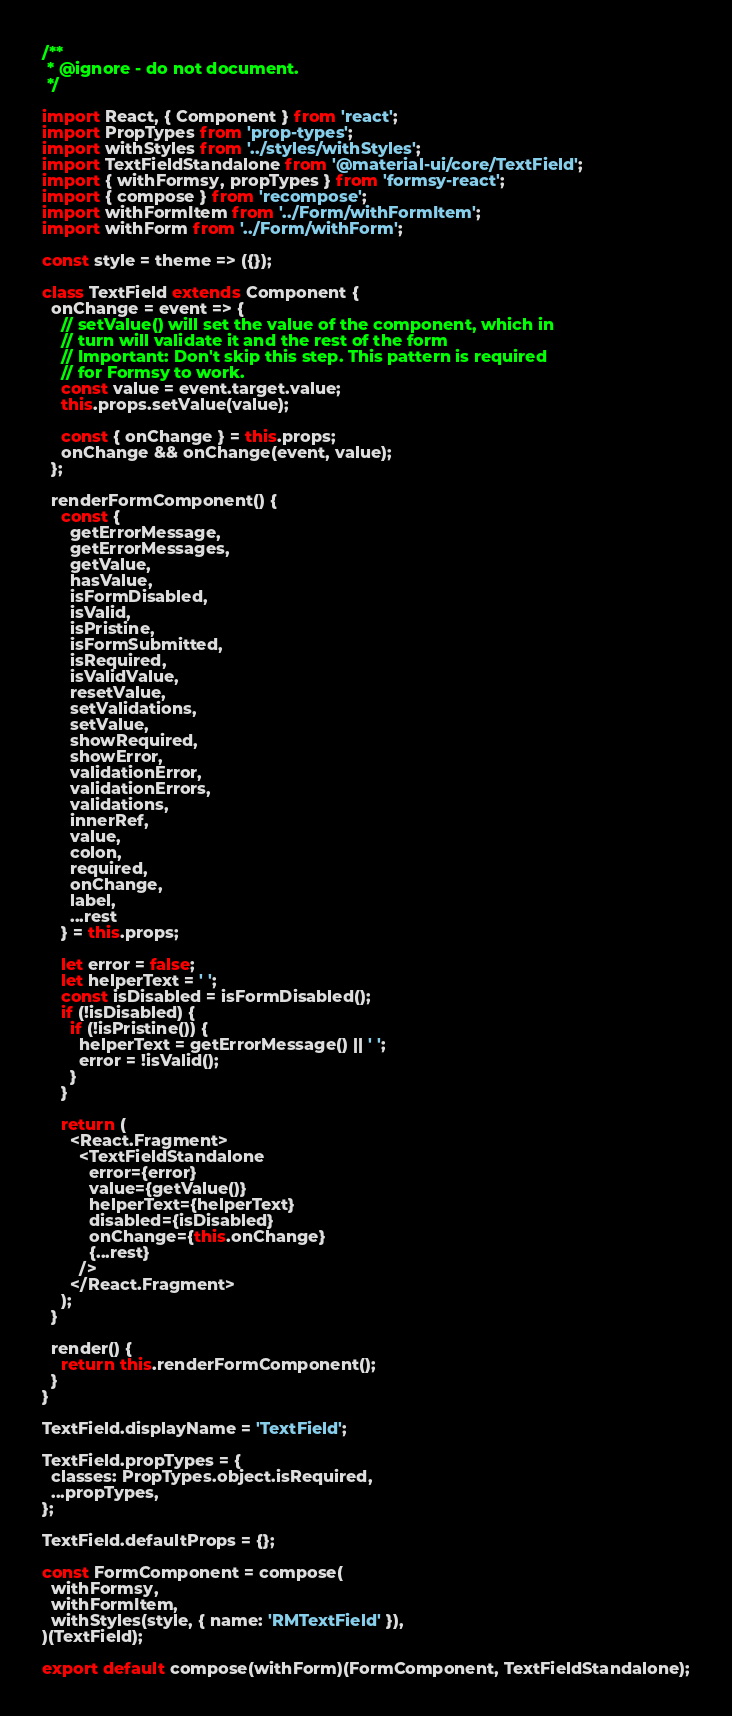<code> <loc_0><loc_0><loc_500><loc_500><_JavaScript_>/**
 * @ignore - do not document.
 */

import React, { Component } from 'react';
import PropTypes from 'prop-types';
import withStyles from '../styles/withStyles';
import TextFieldStandalone from '@material-ui/core/TextField';
import { withFormsy, propTypes } from 'formsy-react';
import { compose } from 'recompose';
import withFormItem from '../Form/withFormItem';
import withForm from '../Form/withForm';

const style = theme => ({});

class TextField extends Component {
  onChange = event => {
    // setValue() will set the value of the component, which in
    // turn will validate it and the rest of the form
    // Important: Don't skip this step. This pattern is required
    // for Formsy to work.
    const value = event.target.value;
    this.props.setValue(value);

    const { onChange } = this.props;
    onChange && onChange(event, value);
  };

  renderFormComponent() {
    const {
      getErrorMessage,
      getErrorMessages,
      getValue,
      hasValue,
      isFormDisabled,
      isValid,
      isPristine,
      isFormSubmitted,
      isRequired,
      isValidValue,
      resetValue,
      setValidations,
      setValue,
      showRequired,
      showError,
      validationError,
      validationErrors,
      validations,
      innerRef,
      value,
      colon,
      required,
      onChange,
      label,
      ...rest
    } = this.props;

    let error = false;
    let helperText = ' ';
    const isDisabled = isFormDisabled();
    if (!isDisabled) {
      if (!isPristine()) {
        helperText = getErrorMessage() || ' ';
        error = !isValid();
      }
    }

    return (
      <React.Fragment>
        <TextFieldStandalone
          error={error}
          value={getValue()}
          helperText={helperText}
          disabled={isDisabled}
          onChange={this.onChange}
          {...rest}
        />
      </React.Fragment>
    );
  }

  render() {
    return this.renderFormComponent();
  }
}

TextField.displayName = 'TextField';

TextField.propTypes = {
  classes: PropTypes.object.isRequired,
  ...propTypes,
};

TextField.defaultProps = {};

const FormComponent = compose(
  withFormsy,
  withFormItem,
  withStyles(style, { name: 'RMTextField' }),
)(TextField);

export default compose(withForm)(FormComponent, TextFieldStandalone);
</code> 